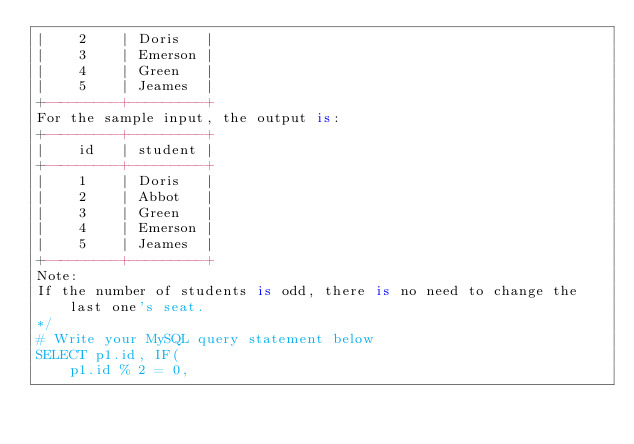<code> <loc_0><loc_0><loc_500><loc_500><_SQL_>|    2    | Doris   |
|    3    | Emerson |
|    4    | Green   |
|    5    | Jeames  |
+---------+---------+
For the sample input, the output is:
+---------+---------+
|    id   | student |
+---------+---------+
|    1    | Doris   |
|    2    | Abbot   |
|    3    | Green   |
|    4    | Emerson |
|    5    | Jeames  |
+---------+---------+
Note:
If the number of students is odd, there is no need to change the last one's seat.
*/
# Write your MySQL query statement below
SELECT p1.id, IF(
    p1.id % 2 = 0, </code> 